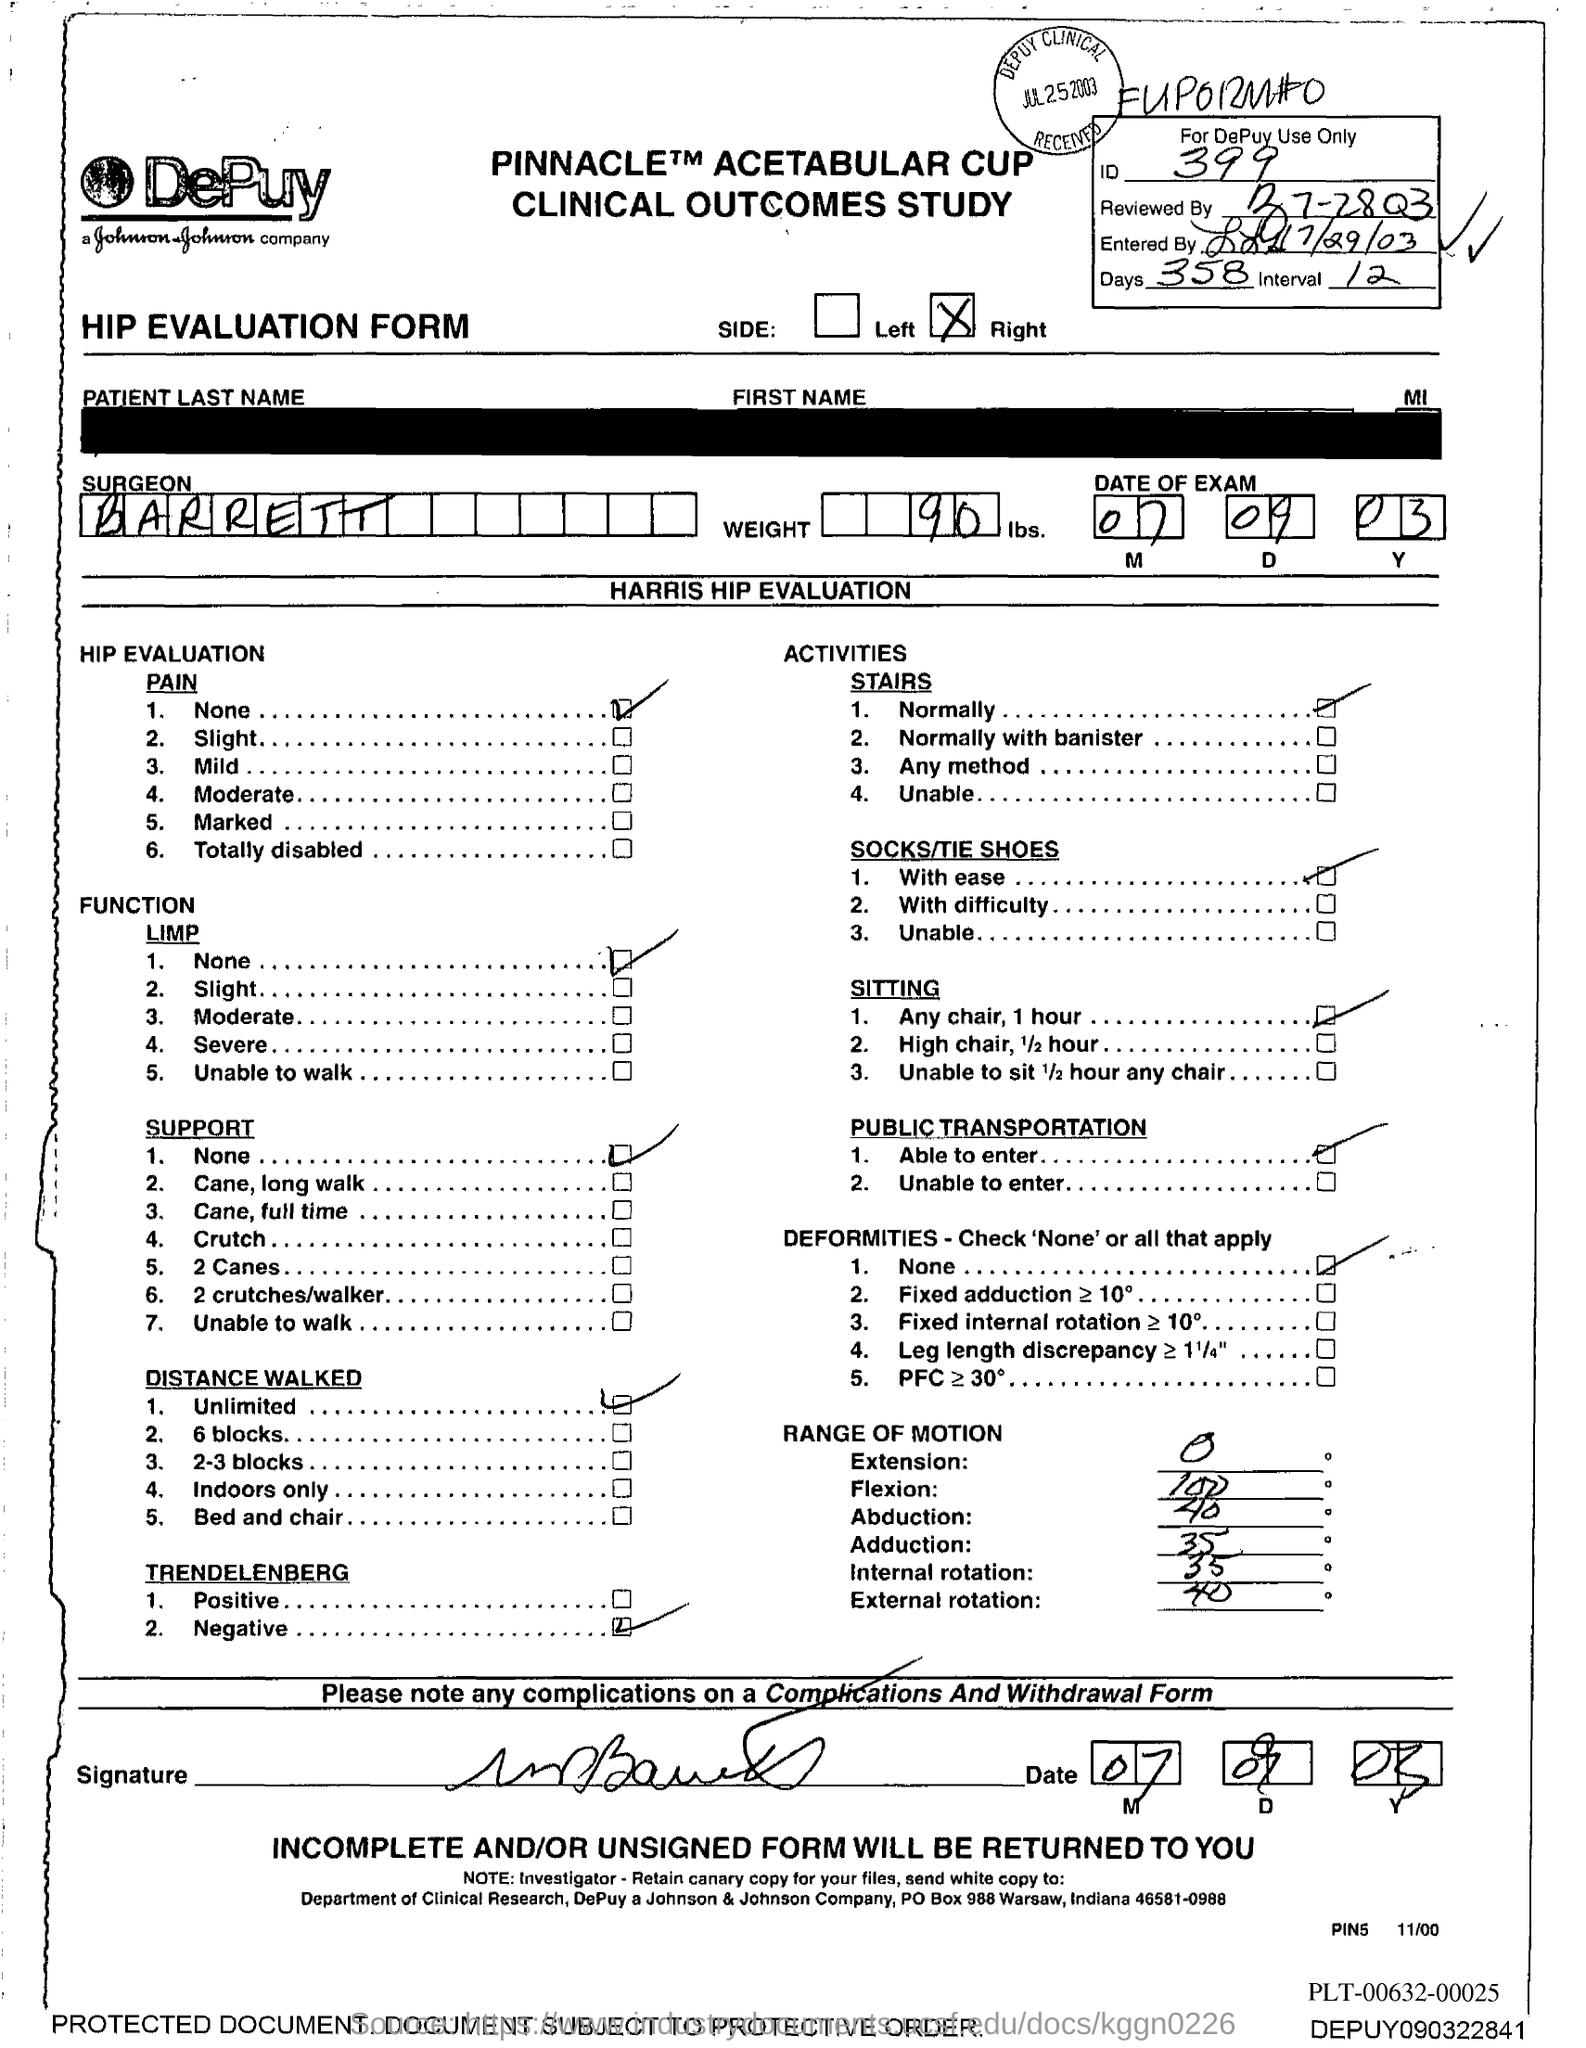Mention a couple of crucial points in this snapshot. The ID number is 399. The number of days is 358. The surgeon's name is Barrett. The weight is 90... 